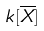Convert formula to latex. <formula><loc_0><loc_0><loc_500><loc_500>k [ \overline { X } ]</formula> 